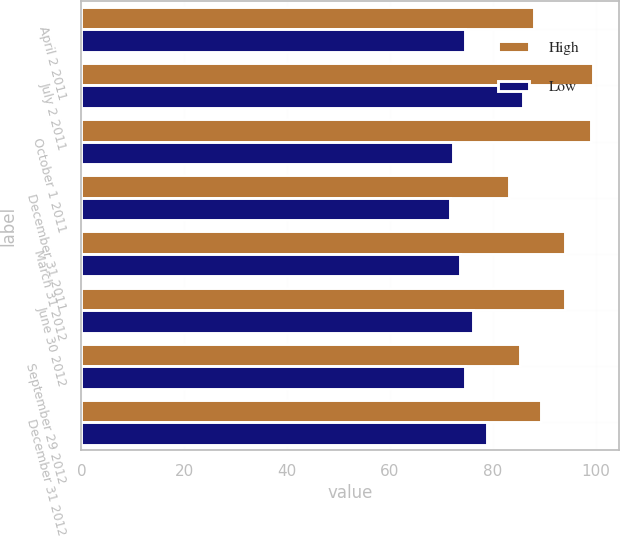Convert chart. <chart><loc_0><loc_0><loc_500><loc_500><stacked_bar_chart><ecel><fcel>April 2 2011<fcel>July 2 2011<fcel>October 1 2011<fcel>December 31 2011<fcel>March 31 2012<fcel>June 30 2012<fcel>September 29 2012<fcel>December 31 2012<nl><fcel>High<fcel>87.93<fcel>99.56<fcel>99.16<fcel>83.14<fcel>94.03<fcel>93.99<fcel>85.24<fcel>89.33<nl><fcel>Low<fcel>74.68<fcel>85.96<fcel>72.19<fcel>71.61<fcel>73.71<fcel>76.15<fcel>74.66<fcel>78.89<nl></chart> 